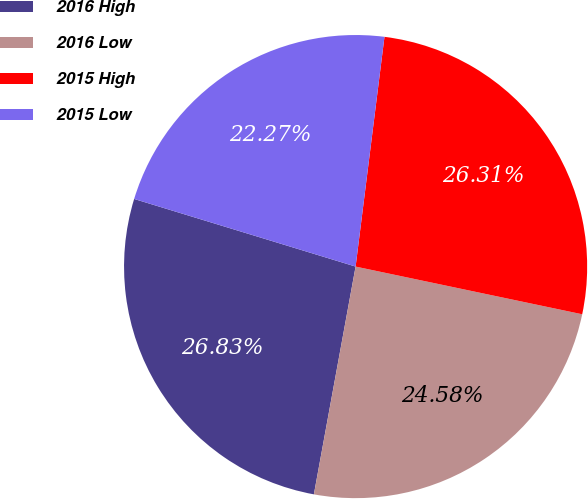<chart> <loc_0><loc_0><loc_500><loc_500><pie_chart><fcel>2016 High<fcel>2016 Low<fcel>2015 High<fcel>2015 Low<nl><fcel>26.83%<fcel>24.58%<fcel>26.31%<fcel>22.27%<nl></chart> 